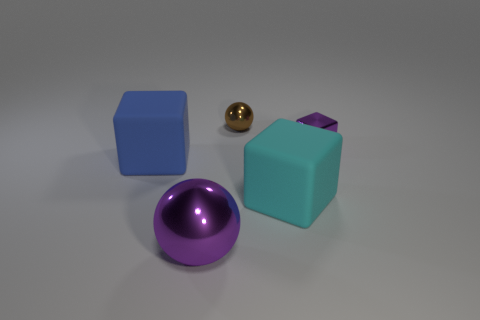Is the color of the shiny cube the same as the object behind the purple block? no 